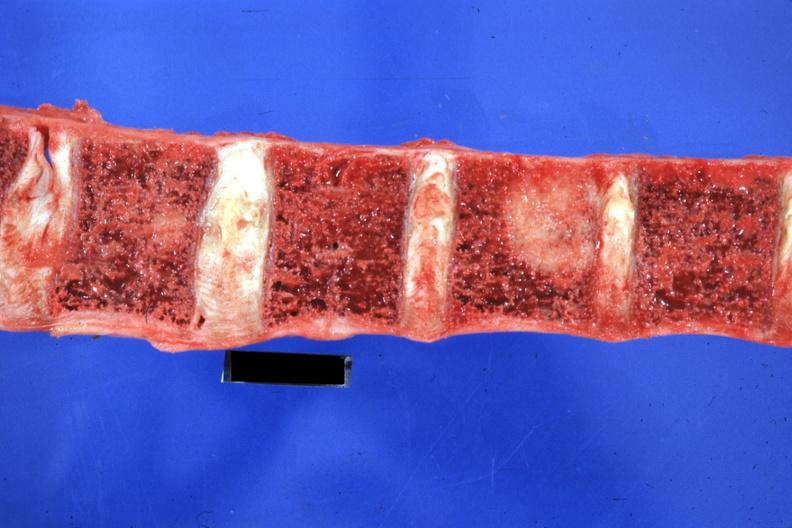what is present?
Answer the question using a single word or phrase. Joints 